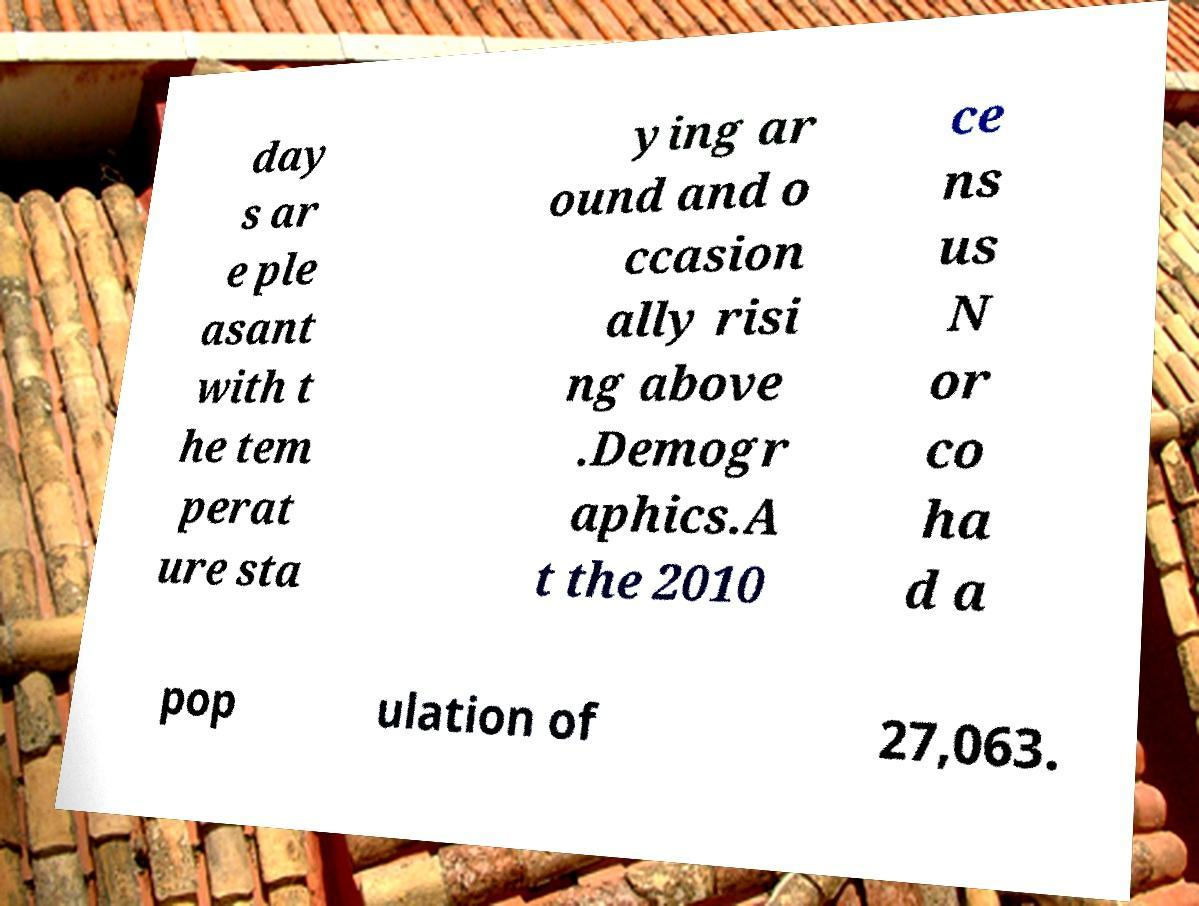Could you extract and type out the text from this image? day s ar e ple asant with t he tem perat ure sta ying ar ound and o ccasion ally risi ng above .Demogr aphics.A t the 2010 ce ns us N or co ha d a pop ulation of 27,063. 